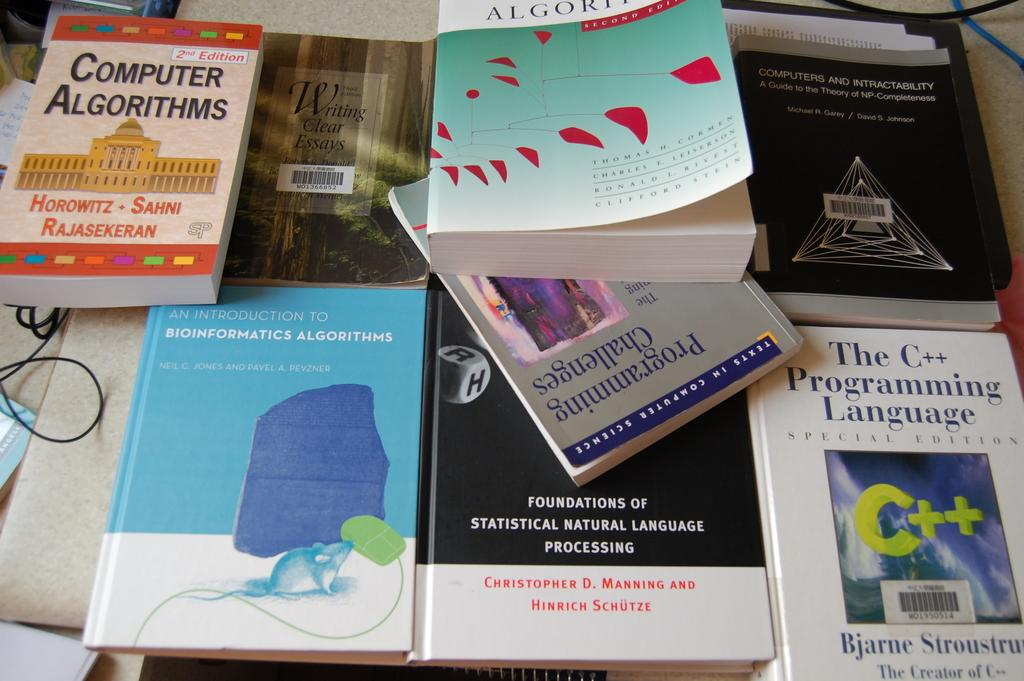<image>
Create a compact narrative representing the image presented. A book about C++ programming language sits near several other computer science books. 